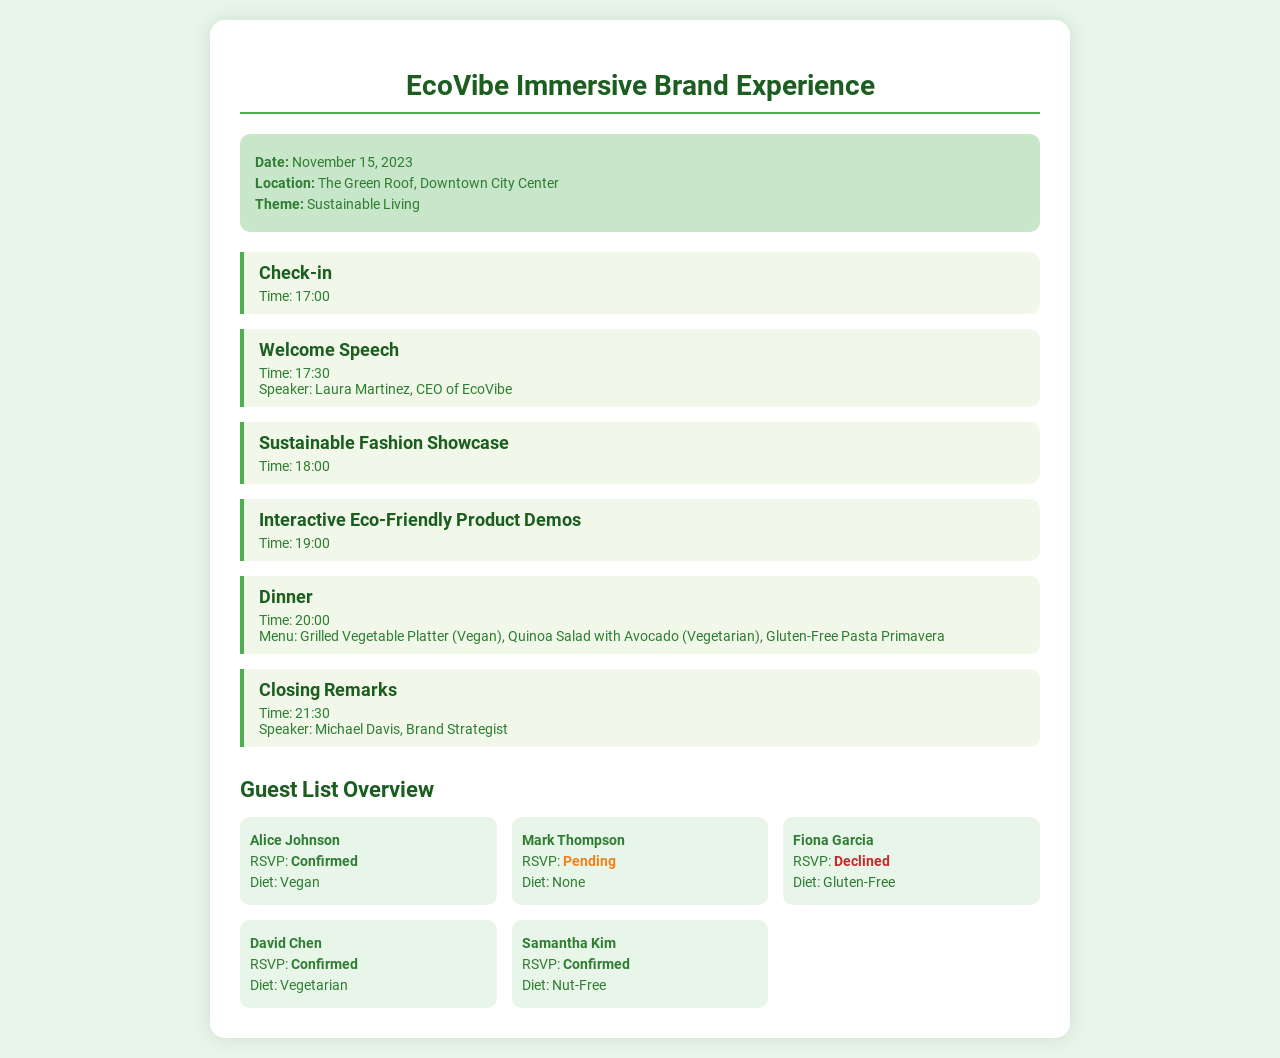What is the date of the event? The date of the event is explicitly listed in the document under event details.
Answer: November 15, 2023 What is the location of the event? The event's location is mentioned in the event details section.
Answer: The Green Roof, Downtown City Center Who is the speaker during the Welcome Speech? The speaker's name is provided in the schedule section for the Welcome Speech.
Answer: Laura Martinez What time does the dinner start? The start time for dinner is stated in the schedule section for Dinner.
Answer: 20:00 What dietary preference does Alice Johnson have? Alice Johnson's dietary preference is listed in her guest item in the guest list.
Answer: Vegan How many guests have confirmed their RSVP? The number of confirmed guests can be counted from the guest list overview.
Answer: Three What is the theme of the event? The theme can be found in the event details section of the document.
Answer: Sustainable Living What is the menu option for gluten-free diners? The menu for gluten-free diners is mentioned in the dinner schedule item.
Answer: Gluten-Free Pasta Primavera Who is giving the closing remarks? The person giving the closing remarks is noted in the schedule section.
Answer: Michael Davis 